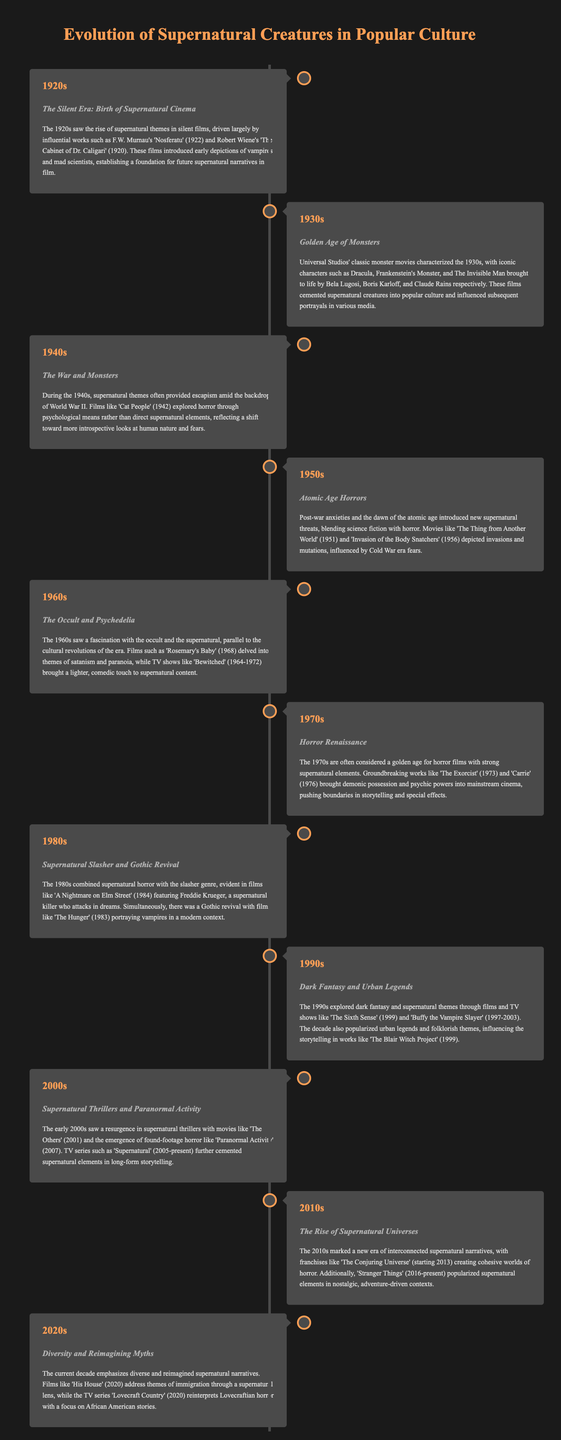what year did 'Nosferatu' release? 'Nosferatu' is mentioned as a significant film from the 1920s, specifically released in 1922.
Answer: 1922 which supernatural movie features a demon and was released in 1973? The title 'The Exorcist' is listed under the 1970s as a groundbreaking horror film involving demonic possession.
Answer: The Exorcist what significant theme emerged in the 1940s regarding supernatural content? The 1940s introduced psychological explorations of horror, as noted in the description of 'Cat People'.
Answer: Psychological which decade saw the release of 'Buffy the Vampire Slayer'? 'Buffy the Vampire Slayer' is mentioned in the 1990s section as a pivotal show.
Answer: 1990s name a TV series that began in the 2000s featuring supernatural elements. The document states that 'Supernatural' started airing in the 2000s, contributing to long-form storytelling.
Answer: Supernatural how did supernatural narratives evolve in the 2010s? The 2010s are noted for interconnected narratives, as exemplified by 'The Conjuring Universe'.
Answer: Interconnected what new perspective does 'His House' introduce in the 2020s? The film 'His House' addresses themes of immigration through a supernatural lens, reflecting a fresh narrative approach.
Answer: Immigration which genre was blended in the 1980s with supernatural themes? The document highlights the combination of supernatural horror with the slasher genre in the 1980s.
Answer: Slasher what type of films characterized the 1930s? The 1930s are characterized by Universal Studios’ monster movies, fostering iconic horror characters.
Answer: Monster movies 